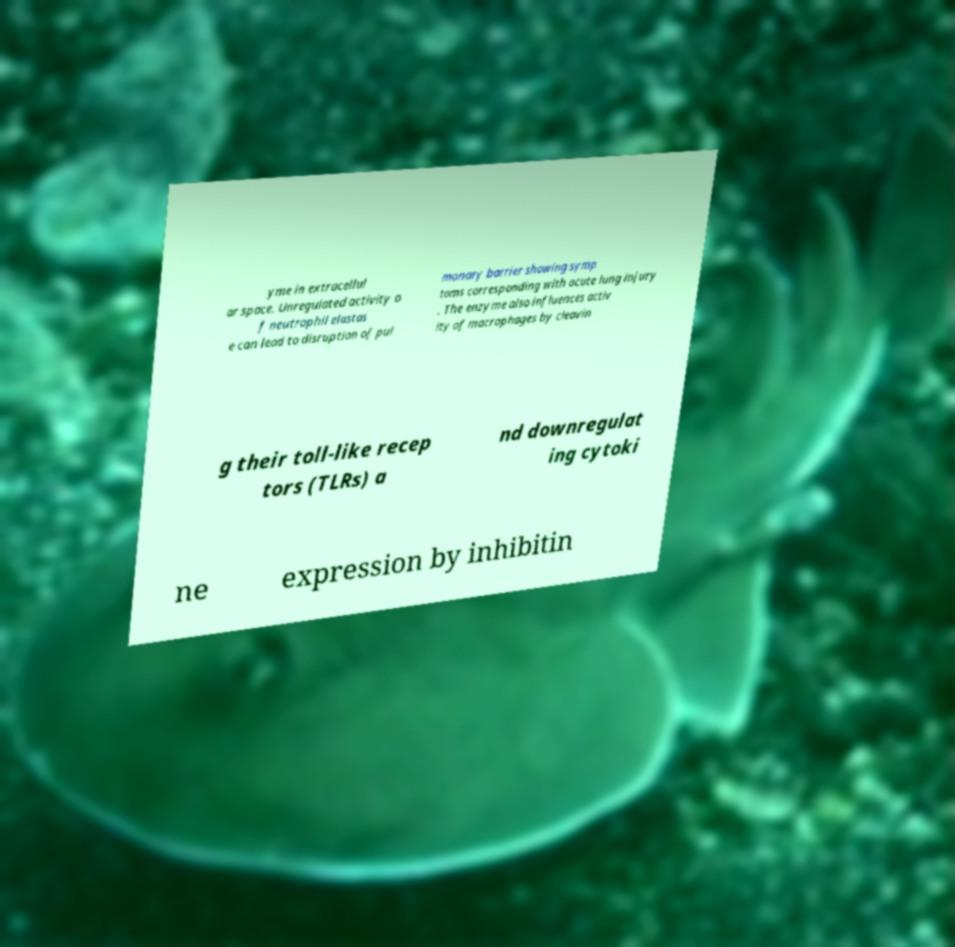Can you accurately transcribe the text from the provided image for me? yme in extracellul ar space. Unregulated activity o f neutrophil elastas e can lead to disruption of pul monary barrier showing symp toms corresponding with acute lung injury . The enzyme also influences activ ity of macrophages by cleavin g their toll-like recep tors (TLRs) a nd downregulat ing cytoki ne expression by inhibitin 